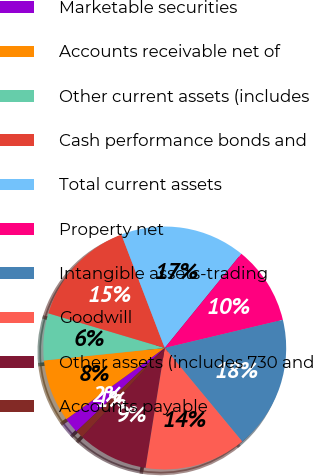<chart> <loc_0><loc_0><loc_500><loc_500><pie_chart><fcel>Marketable securities<fcel>Accounts receivable net of<fcel>Other current assets (includes<fcel>Cash performance bonds and<fcel>Total current assets<fcel>Property net<fcel>Intangible assets-trading<fcel>Goodwill<fcel>Other assets (includes 730 and<fcel>Accounts payable<nl><fcel>2.08%<fcel>8.33%<fcel>6.25%<fcel>14.58%<fcel>16.67%<fcel>10.42%<fcel>17.71%<fcel>13.54%<fcel>9.38%<fcel>1.04%<nl></chart> 